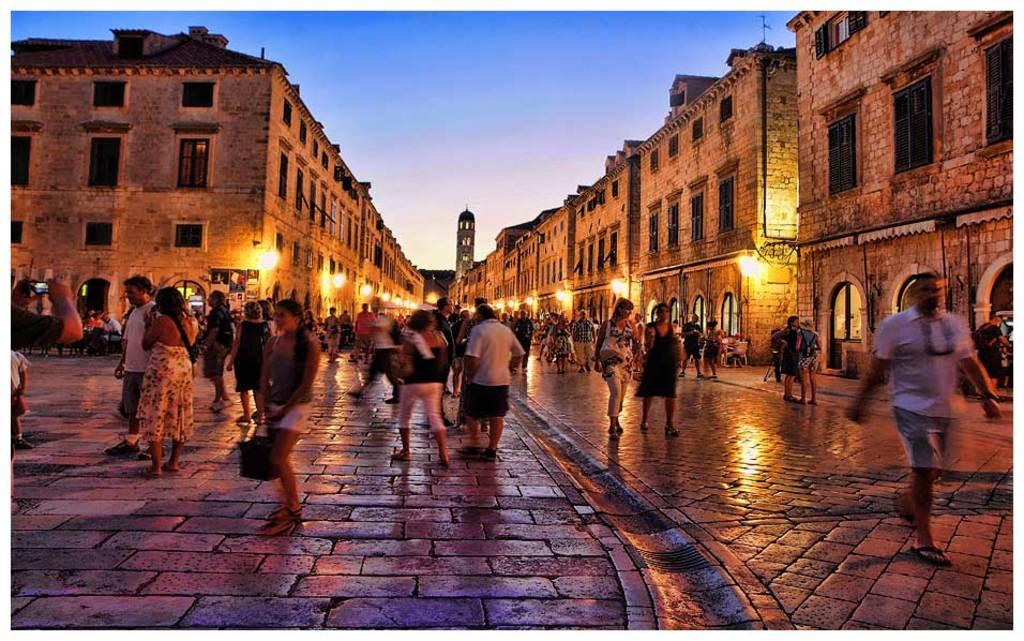What is happening in the foreground of the image? There are many persons moving on the ground in the foreground of the image. What can be seen in the background of the image? There are buildings and lights visible in the background of the image. What is the condition of the sky in the image? The sky is visible in the background of the image. Can you tell me how many friends the queen has in the image? There is no queen or friends mentioned in the image; it features persons moving on the ground and buildings, lights, and the sky in the background. What type of bubble can be seen in the image? There is no bubble present in the image. 